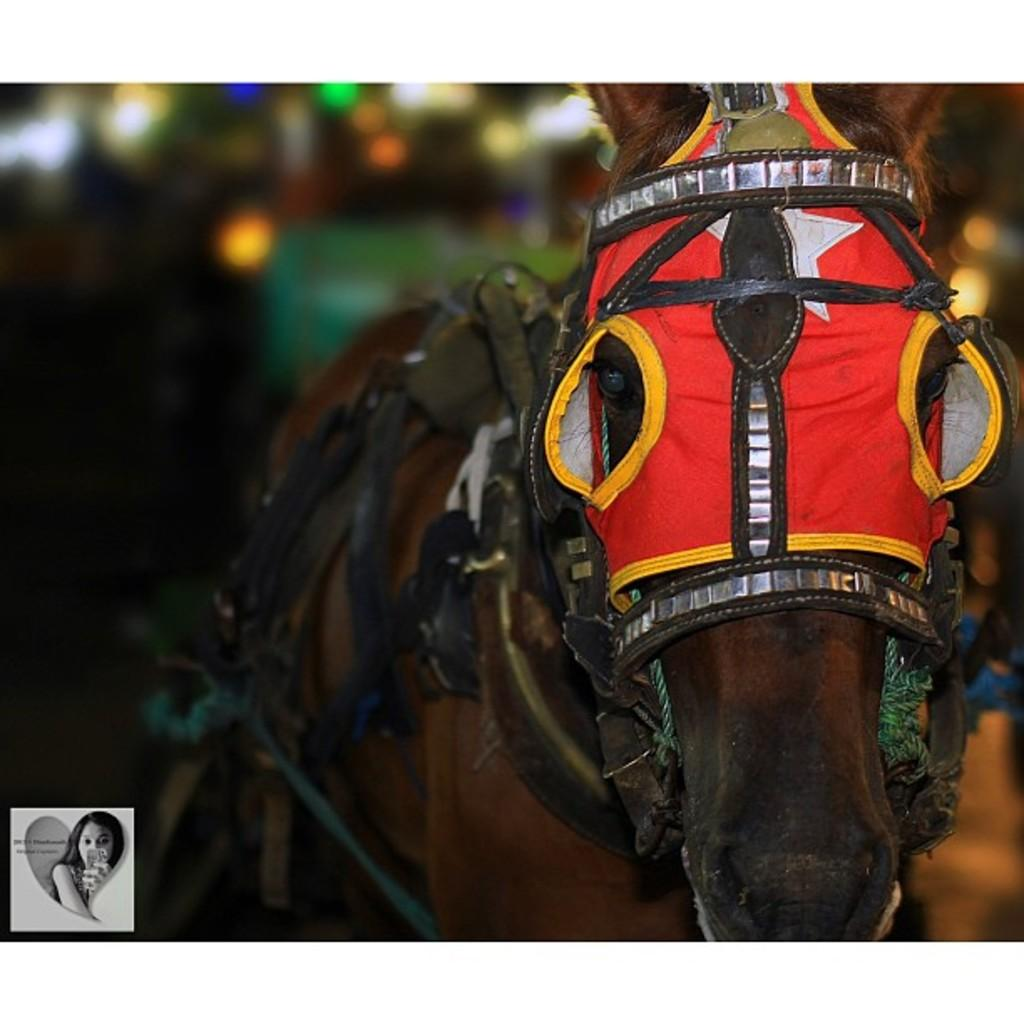What is the main subject in the center of the image? There is a house in the center of the image. Where is the house located in relation to the floor? The house is on the floor. What type of ice can be seen melting on the roof of the house in the image? There is no ice visible on the roof of the house in the image. 